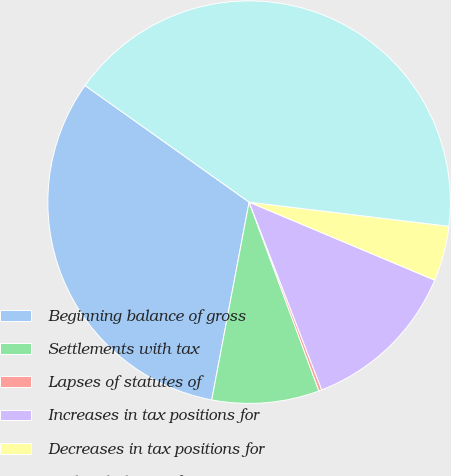Convert chart. <chart><loc_0><loc_0><loc_500><loc_500><pie_chart><fcel>Beginning balance of gross<fcel>Settlements with tax<fcel>Lapses of statutes of<fcel>Increases in tax positions for<fcel>Decreases in tax positions for<fcel>Ending balance of gross<nl><fcel>31.86%<fcel>8.61%<fcel>0.24%<fcel>12.79%<fcel>4.42%<fcel>42.08%<nl></chart> 